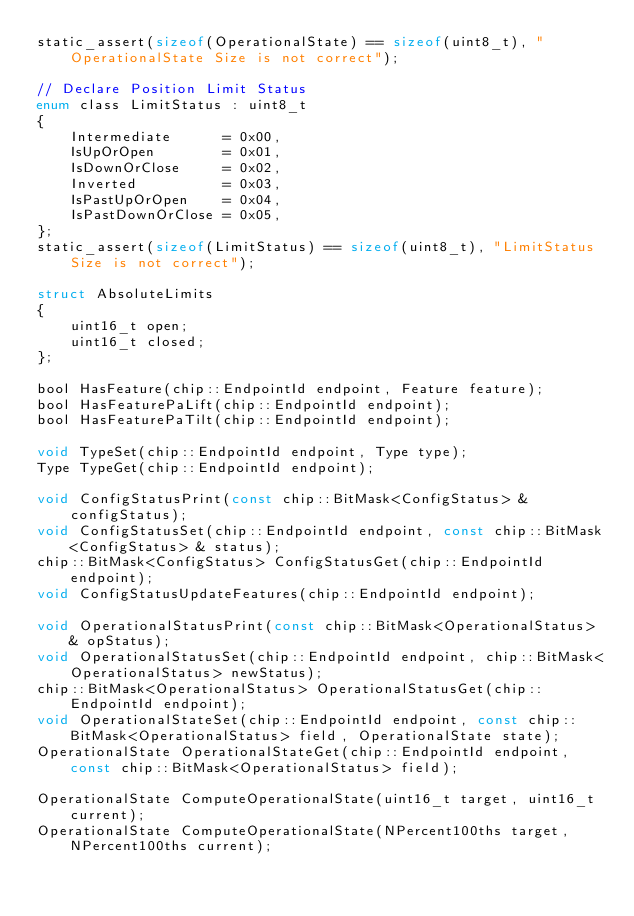Convert code to text. <code><loc_0><loc_0><loc_500><loc_500><_C_>static_assert(sizeof(OperationalState) == sizeof(uint8_t), "OperationalState Size is not correct");

// Declare Position Limit Status
enum class LimitStatus : uint8_t
{
    Intermediate      = 0x00,
    IsUpOrOpen        = 0x01,
    IsDownOrClose     = 0x02,
    Inverted          = 0x03,
    IsPastUpOrOpen    = 0x04,
    IsPastDownOrClose = 0x05,
};
static_assert(sizeof(LimitStatus) == sizeof(uint8_t), "LimitStatus Size is not correct");

struct AbsoluteLimits
{
    uint16_t open;
    uint16_t closed;
};

bool HasFeature(chip::EndpointId endpoint, Feature feature);
bool HasFeaturePaLift(chip::EndpointId endpoint);
bool HasFeaturePaTilt(chip::EndpointId endpoint);

void TypeSet(chip::EndpointId endpoint, Type type);
Type TypeGet(chip::EndpointId endpoint);

void ConfigStatusPrint(const chip::BitMask<ConfigStatus> & configStatus);
void ConfigStatusSet(chip::EndpointId endpoint, const chip::BitMask<ConfigStatus> & status);
chip::BitMask<ConfigStatus> ConfigStatusGet(chip::EndpointId endpoint);
void ConfigStatusUpdateFeatures(chip::EndpointId endpoint);

void OperationalStatusPrint(const chip::BitMask<OperationalStatus> & opStatus);
void OperationalStatusSet(chip::EndpointId endpoint, chip::BitMask<OperationalStatus> newStatus);
chip::BitMask<OperationalStatus> OperationalStatusGet(chip::EndpointId endpoint);
void OperationalStateSet(chip::EndpointId endpoint, const chip::BitMask<OperationalStatus> field, OperationalState state);
OperationalState OperationalStateGet(chip::EndpointId endpoint, const chip::BitMask<OperationalStatus> field);

OperationalState ComputeOperationalState(uint16_t target, uint16_t current);
OperationalState ComputeOperationalState(NPercent100ths target, NPercent100ths current);</code> 